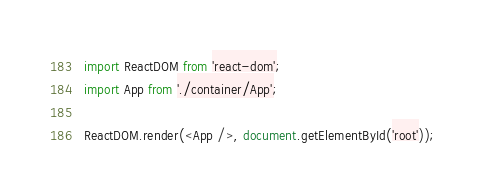Convert code to text. <code><loc_0><loc_0><loc_500><loc_500><_JavaScript_>import ReactDOM from 'react-dom';
import App from './container/App';

ReactDOM.render(<App />, document.getElementById('root'));
</code> 